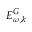<formula> <loc_0><loc_0><loc_500><loc_500>E _ { \omega , k } ^ { G }</formula> 